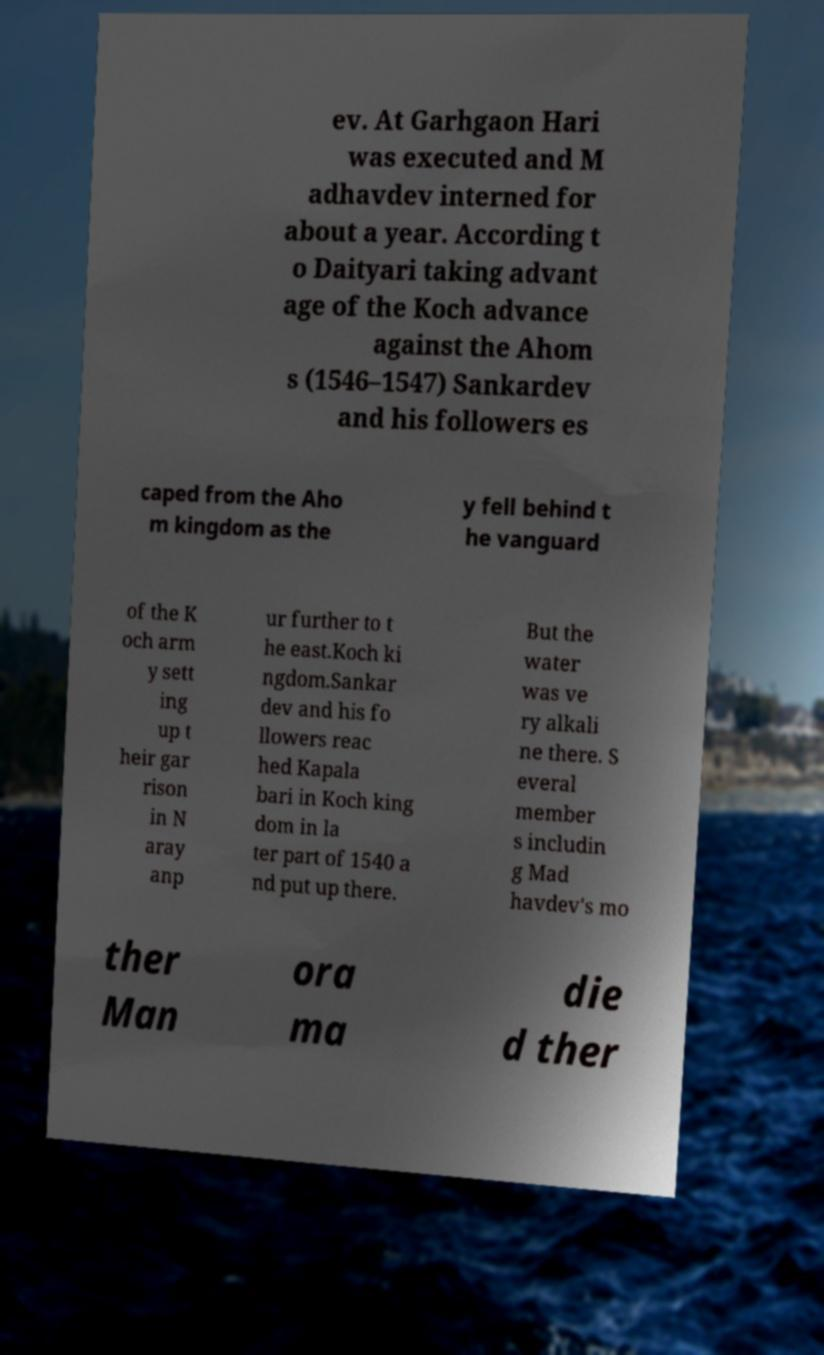Could you assist in decoding the text presented in this image and type it out clearly? ev. At Garhgaon Hari was executed and M adhavdev interned for about a year. According t o Daityari taking advant age of the Koch advance against the Ahom s (1546–1547) Sankardev and his followers es caped from the Aho m kingdom as the y fell behind t he vanguard of the K och arm y sett ing up t heir gar rison in N aray anp ur further to t he east.Koch ki ngdom.Sankar dev and his fo llowers reac hed Kapala bari in Koch king dom in la ter part of 1540 a nd put up there. But the water was ve ry alkali ne there. S everal member s includin g Mad havdev's mo ther Man ora ma die d ther 